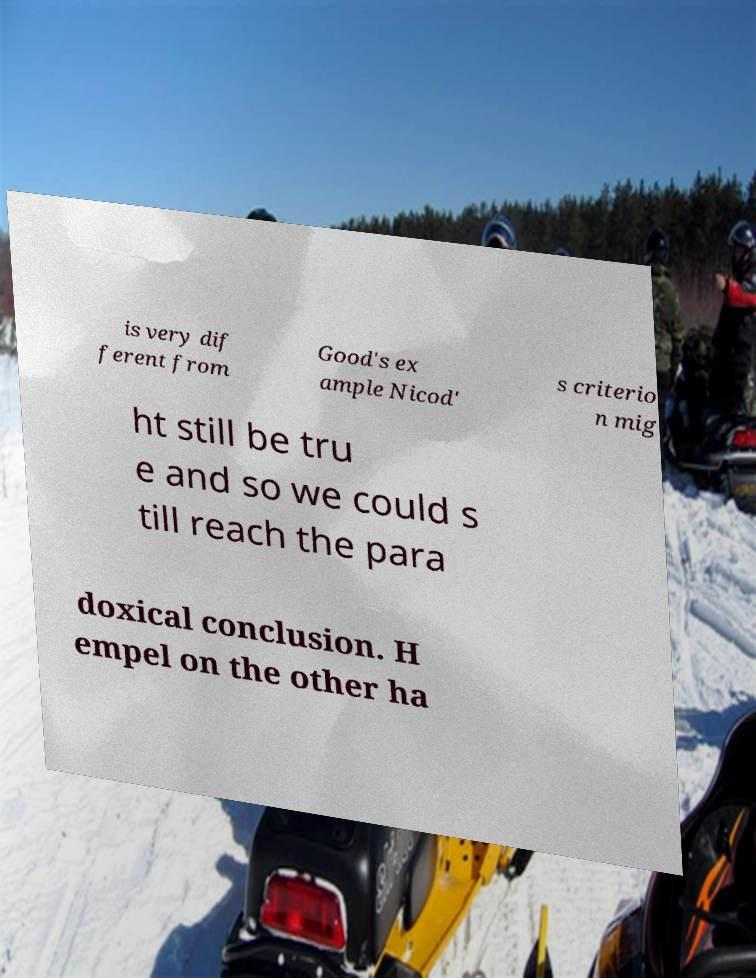Please identify and transcribe the text found in this image. is very dif ferent from Good's ex ample Nicod' s criterio n mig ht still be tru e and so we could s till reach the para doxical conclusion. H empel on the other ha 